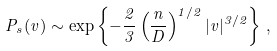<formula> <loc_0><loc_0><loc_500><loc_500>P _ { s } ( v ) \sim \exp \left \{ - \frac { 2 } { 3 } \left ( \frac { n } { D } \right ) ^ { 1 / 2 } | v | ^ { 3 / 2 } \right \} \, ,</formula> 